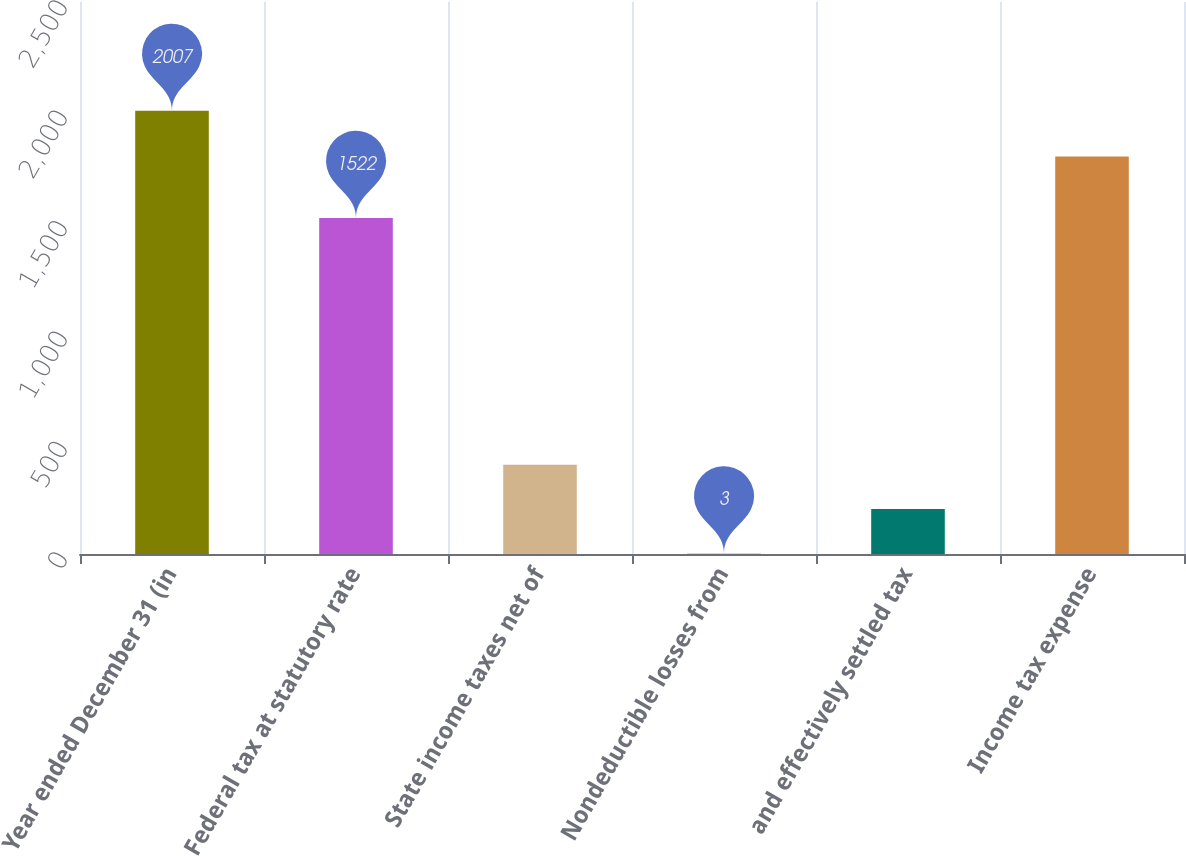Convert chart. <chart><loc_0><loc_0><loc_500><loc_500><bar_chart><fcel>Year ended December 31 (in<fcel>Federal tax at statutory rate<fcel>State income taxes net of<fcel>Nondeductible losses from<fcel>and effectively settled tax<fcel>Income tax expense<nl><fcel>2007<fcel>1522<fcel>403.8<fcel>3<fcel>203.4<fcel>1800<nl></chart> 